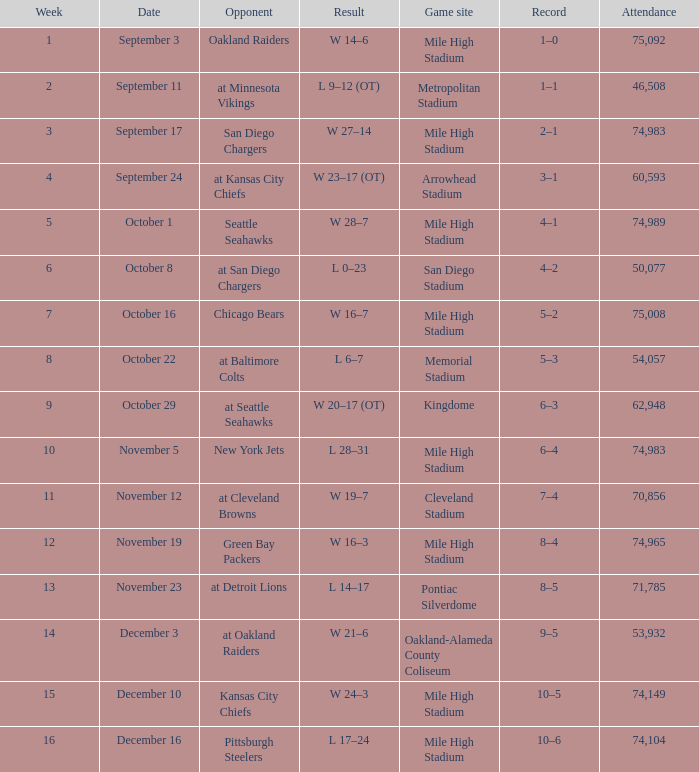When was the outcome recorded as 28-7? October 1. 